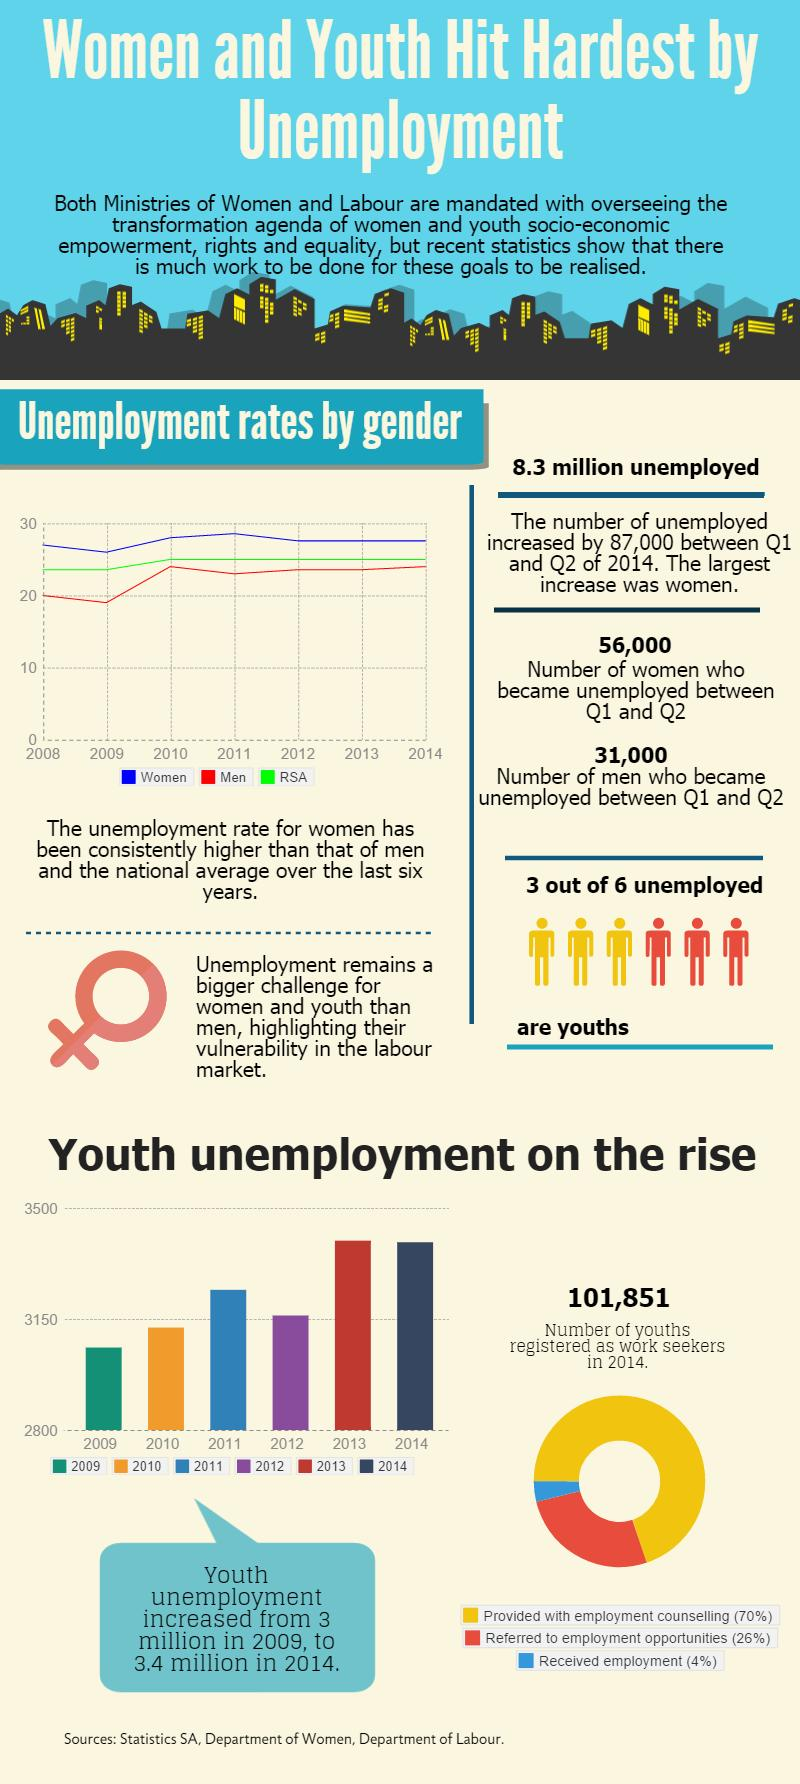List a handful of essential elements in this visual. In the years 2009 and 2010, unemployment was below 3.15%. 